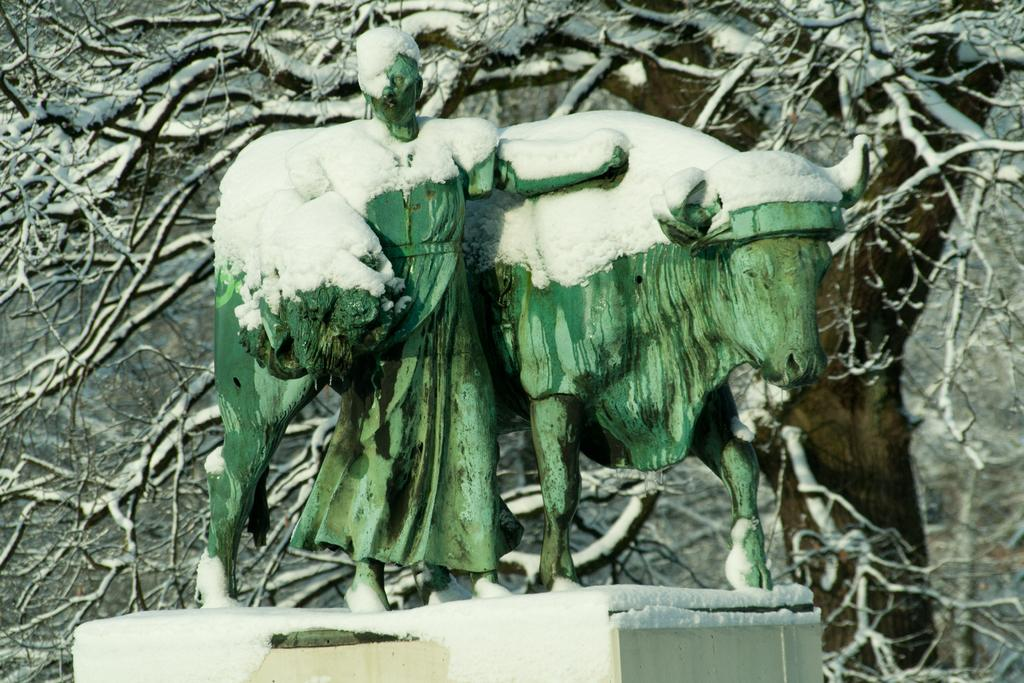What types of statues are present in the image? There is a statue of a person and a statue of an animal in the image. Where are the statues located? Both statues are on a pedestal. What is the weather like in the image? There is snow visible in the image. What can be seen in the background of the image? Branches covered with snow are present in the background of the image. What type of rock is being played in harmony in the image? There is no rock or musical instrument present in the image; it features statues on a pedestal with snow in the background. What type of destruction is depicted in the image? There is no destruction depicted in the image; it features statues on a pedestal with snow in the background. 